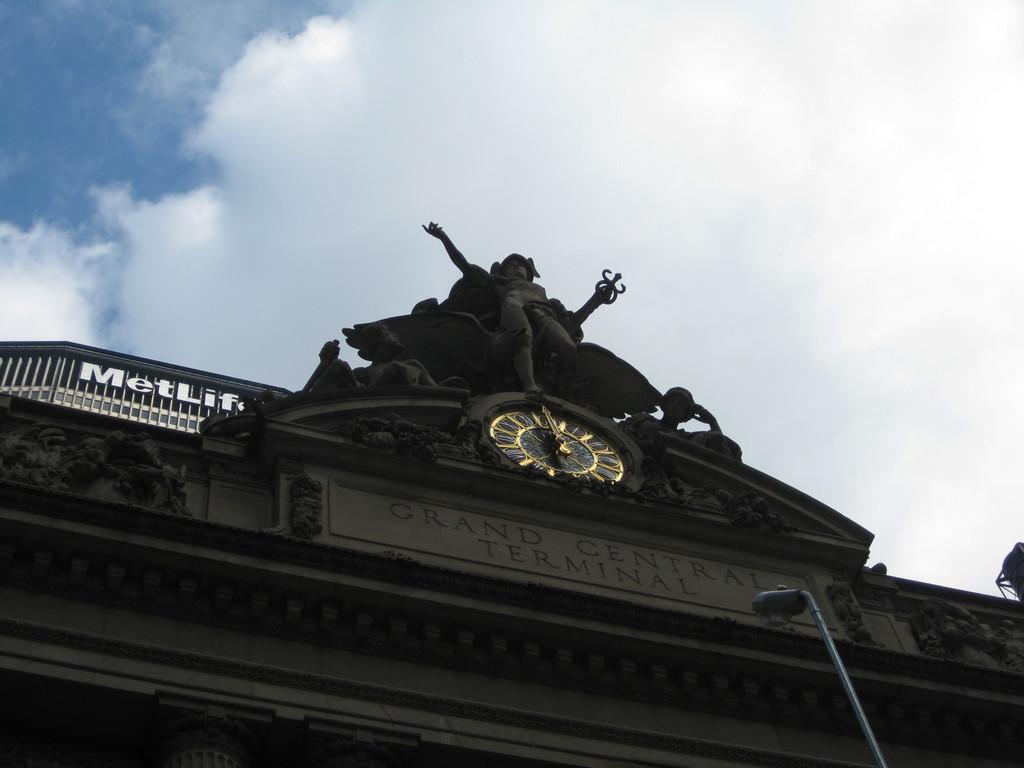Provide a one-sentence caption for the provided image. Looking up at Grand Central Terminal with the MetLife building behind. 